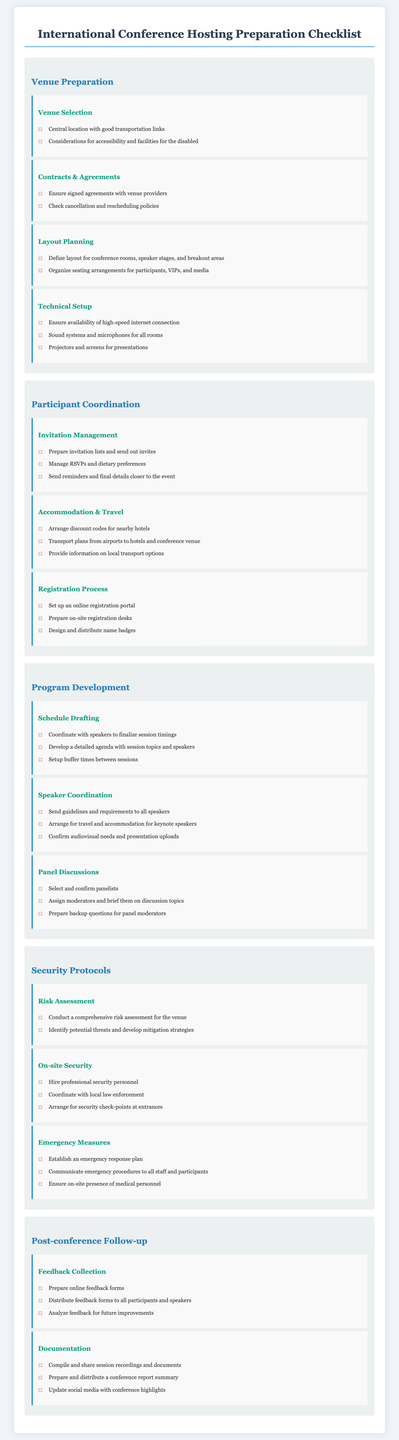What is one key aspect of venue selection? Venue selection should consider central location with good transportation links as a key aspect.
Answer: Central location What should be ensured in contracts and agreements? Contracts and agreements should include signed agreements with venue providers as an essential check.
Answer: Signed agreements What is a necessary component of technical setup? A necessary component of technical setup is ensuring the availability of high-speed internet connection.
Answer: High-speed internet How should participant invitations be managed? Participant invitations should be managed by preparing invitation lists and sending out invites as part of the checklist.
Answer: Prepare invitation lists What is the purpose of conducting a risk assessment? Conducting a risk assessment aims to identify potential threats and develop mitigation strategies for the event.
Answer: Identify threats How many aspects are mentioned under security protocols? There are three aspects specifically mentioned under security protocols in the document.
Answer: Three What should be included in the emergency measures? Emergency measures must include establishing an emergency response plan as a critical element.
Answer: Emergency response plan How is feedback collection planned post-conference? Feedback collection is planned through the preparation of online feedback forms and distribution to all participants.
Answer: Online feedback forms What is a documentation task after the conference? A documentation task is to compile and share session recordings and documents for review and record-keeping.
Answer: Compile session recordings 